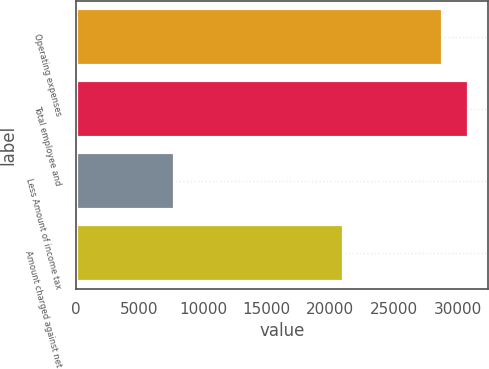<chart> <loc_0><loc_0><loc_500><loc_500><bar_chart><fcel>Operating expenses<fcel>Total employee and<fcel>Less Amount of income tax<fcel>Amount charged against net<nl><fcel>28764<fcel>30867.4<fcel>7730<fcel>21034<nl></chart> 